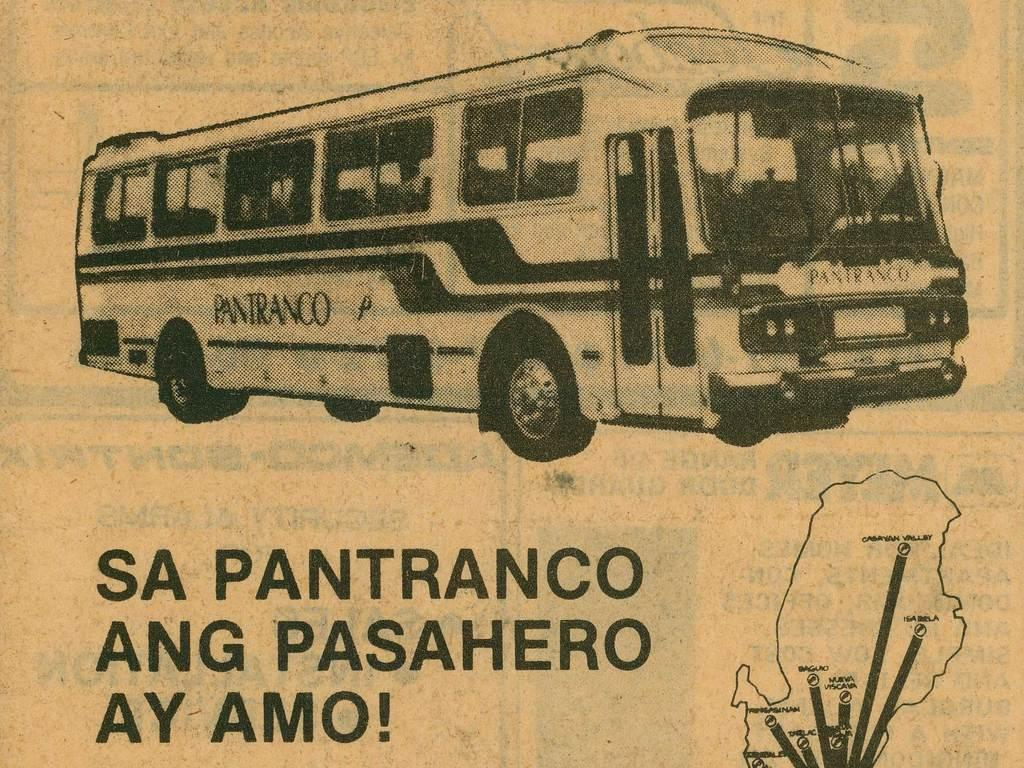What is the color scheme of the image? The image is black and white. What is the main subject of the image? There is a bus in the image. Where is the bus located in the image? The bus is at the top of the image. What other elements are present in the image besides the bus? There is some text and a drawing in the image. Where are the text and drawing located in the image? The text and drawing are at the bottom of the image. What type of texture can be seen on the flesh of the hair in the image? There is no flesh or hair present in the image; it is a black and white image featuring a bus, text, and a drawing. 